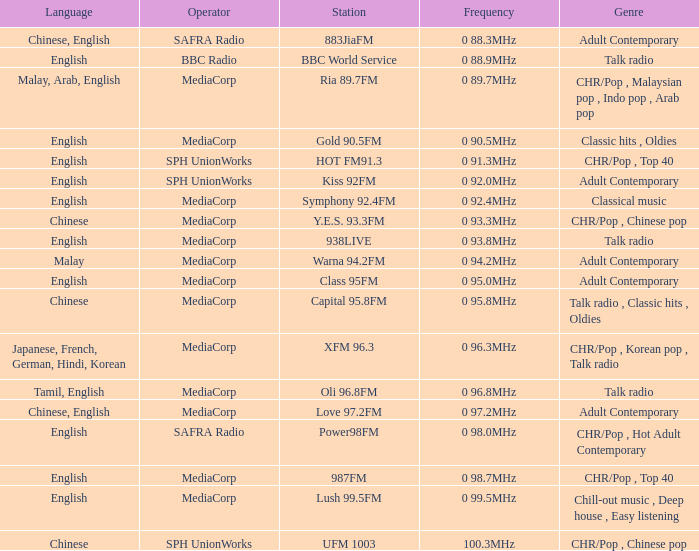Which station is operated by BBC Radio under the talk radio genre? BBC World Service. 